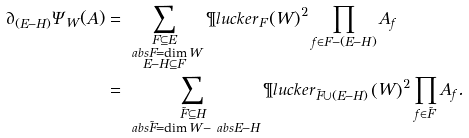Convert formula to latex. <formula><loc_0><loc_0><loc_500><loc_500>\partial _ { ( E - H ) } \Psi _ { W } ( A ) & = \sum _ { \substack { F \subseteq E \\ \ a b s { F } = \dim W \\ E - H \subseteq F } } \P l u c k e r _ { F } \left ( W \right ) ^ { 2 } \prod _ { f \in F - ( E - H ) } A _ { f } \\ & = \sum _ { \substack { \tilde { F } \subseteq H \\ \ a b s { \tilde { F } } = \dim W - \ a b s { E - H } } } \P l u c k e r _ { \tilde { F } \cup ( E - H ) } \left ( W \right ) ^ { 2 } \prod _ { f \in \tilde { F } } A _ { f } .</formula> 